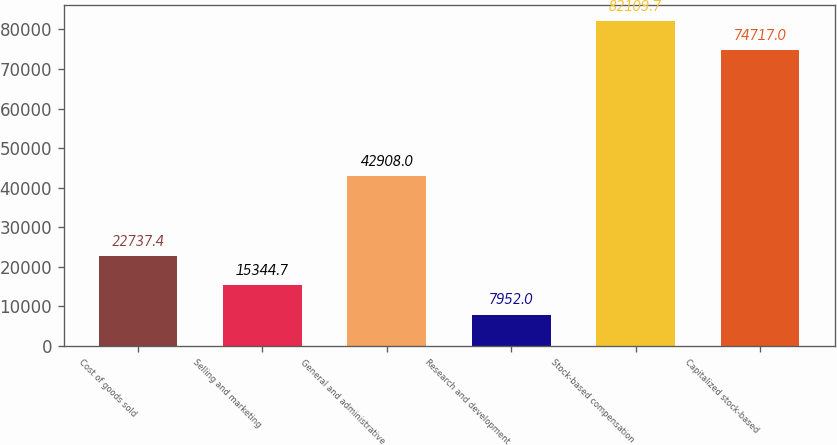<chart> <loc_0><loc_0><loc_500><loc_500><bar_chart><fcel>Cost of goods sold<fcel>Selling and marketing<fcel>General and administrative<fcel>Research and development<fcel>Stock-based compensation<fcel>Capitalized stock-based<nl><fcel>22737.4<fcel>15344.7<fcel>42908<fcel>7952<fcel>82109.7<fcel>74717<nl></chart> 